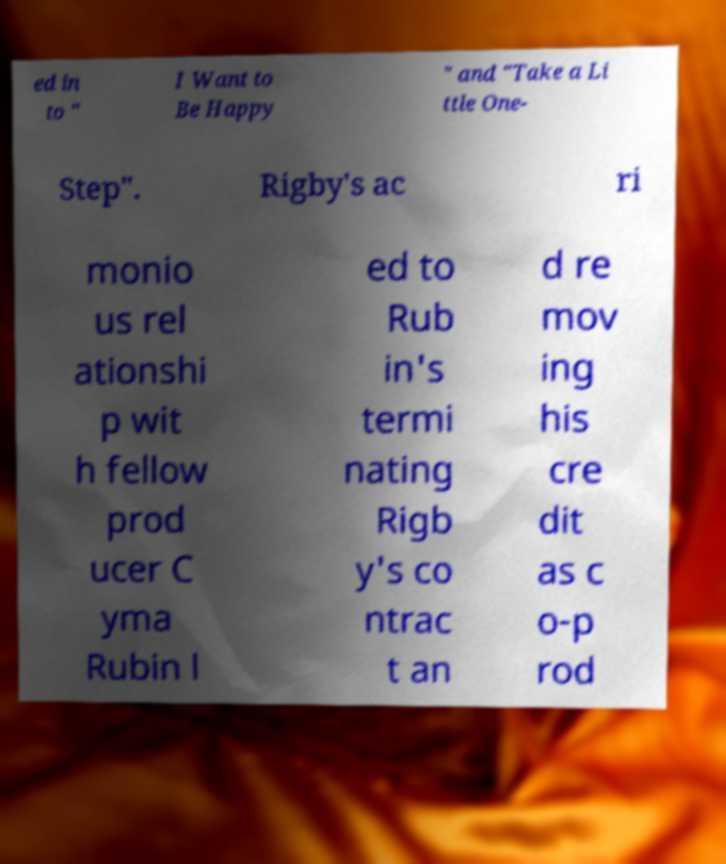Could you extract and type out the text from this image? ed in to " I Want to Be Happy " and "Take a Li ttle One- Step". Rigby's ac ri monio us rel ationshi p wit h fellow prod ucer C yma Rubin l ed to Rub in's termi nating Rigb y's co ntrac t an d re mov ing his cre dit as c o-p rod 